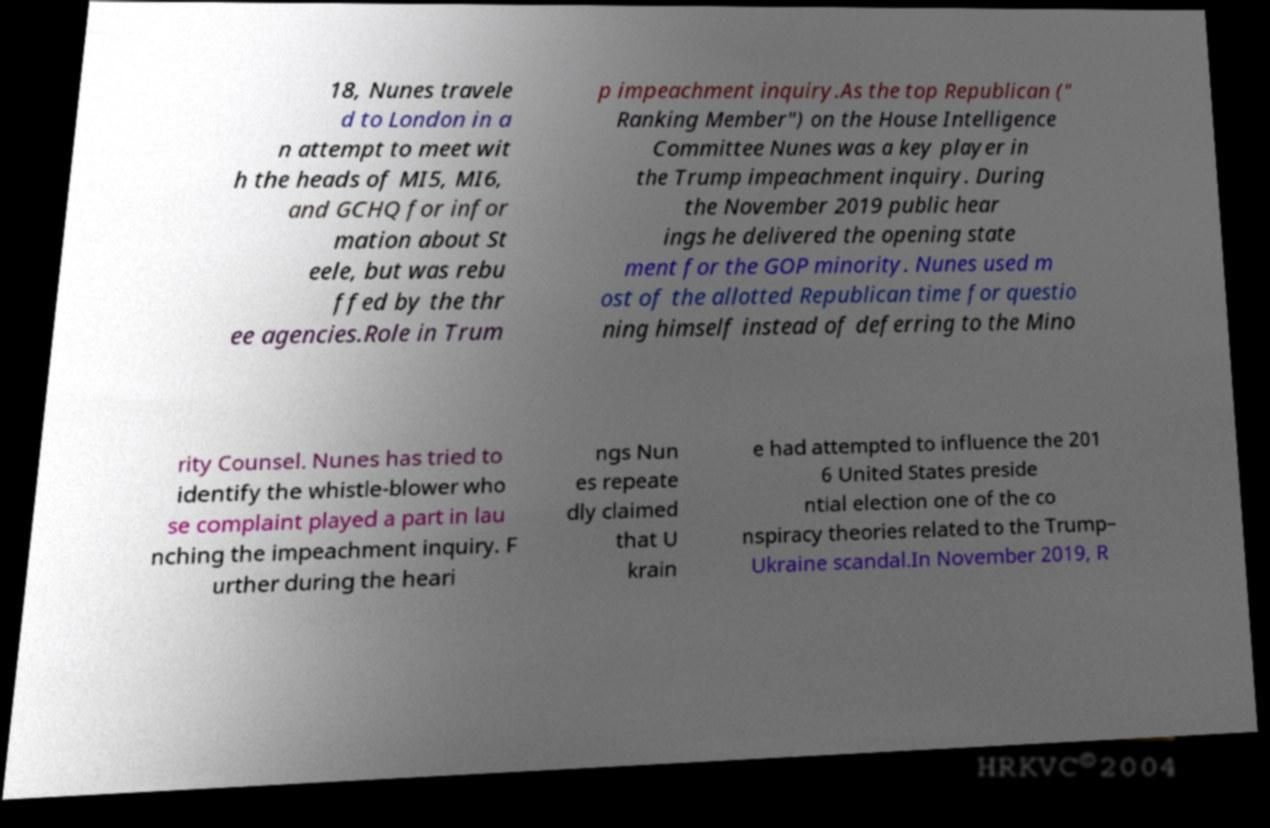Could you extract and type out the text from this image? 18, Nunes travele d to London in a n attempt to meet wit h the heads of MI5, MI6, and GCHQ for infor mation about St eele, but was rebu ffed by the thr ee agencies.Role in Trum p impeachment inquiry.As the top Republican (" Ranking Member") on the House Intelligence Committee Nunes was a key player in the Trump impeachment inquiry. During the November 2019 public hear ings he delivered the opening state ment for the GOP minority. Nunes used m ost of the allotted Republican time for questio ning himself instead of deferring to the Mino rity Counsel. Nunes has tried to identify the whistle-blower who se complaint played a part in lau nching the impeachment inquiry. F urther during the heari ngs Nun es repeate dly claimed that U krain e had attempted to influence the 201 6 United States preside ntial election one of the co nspiracy theories related to the Trump– Ukraine scandal.In November 2019, R 